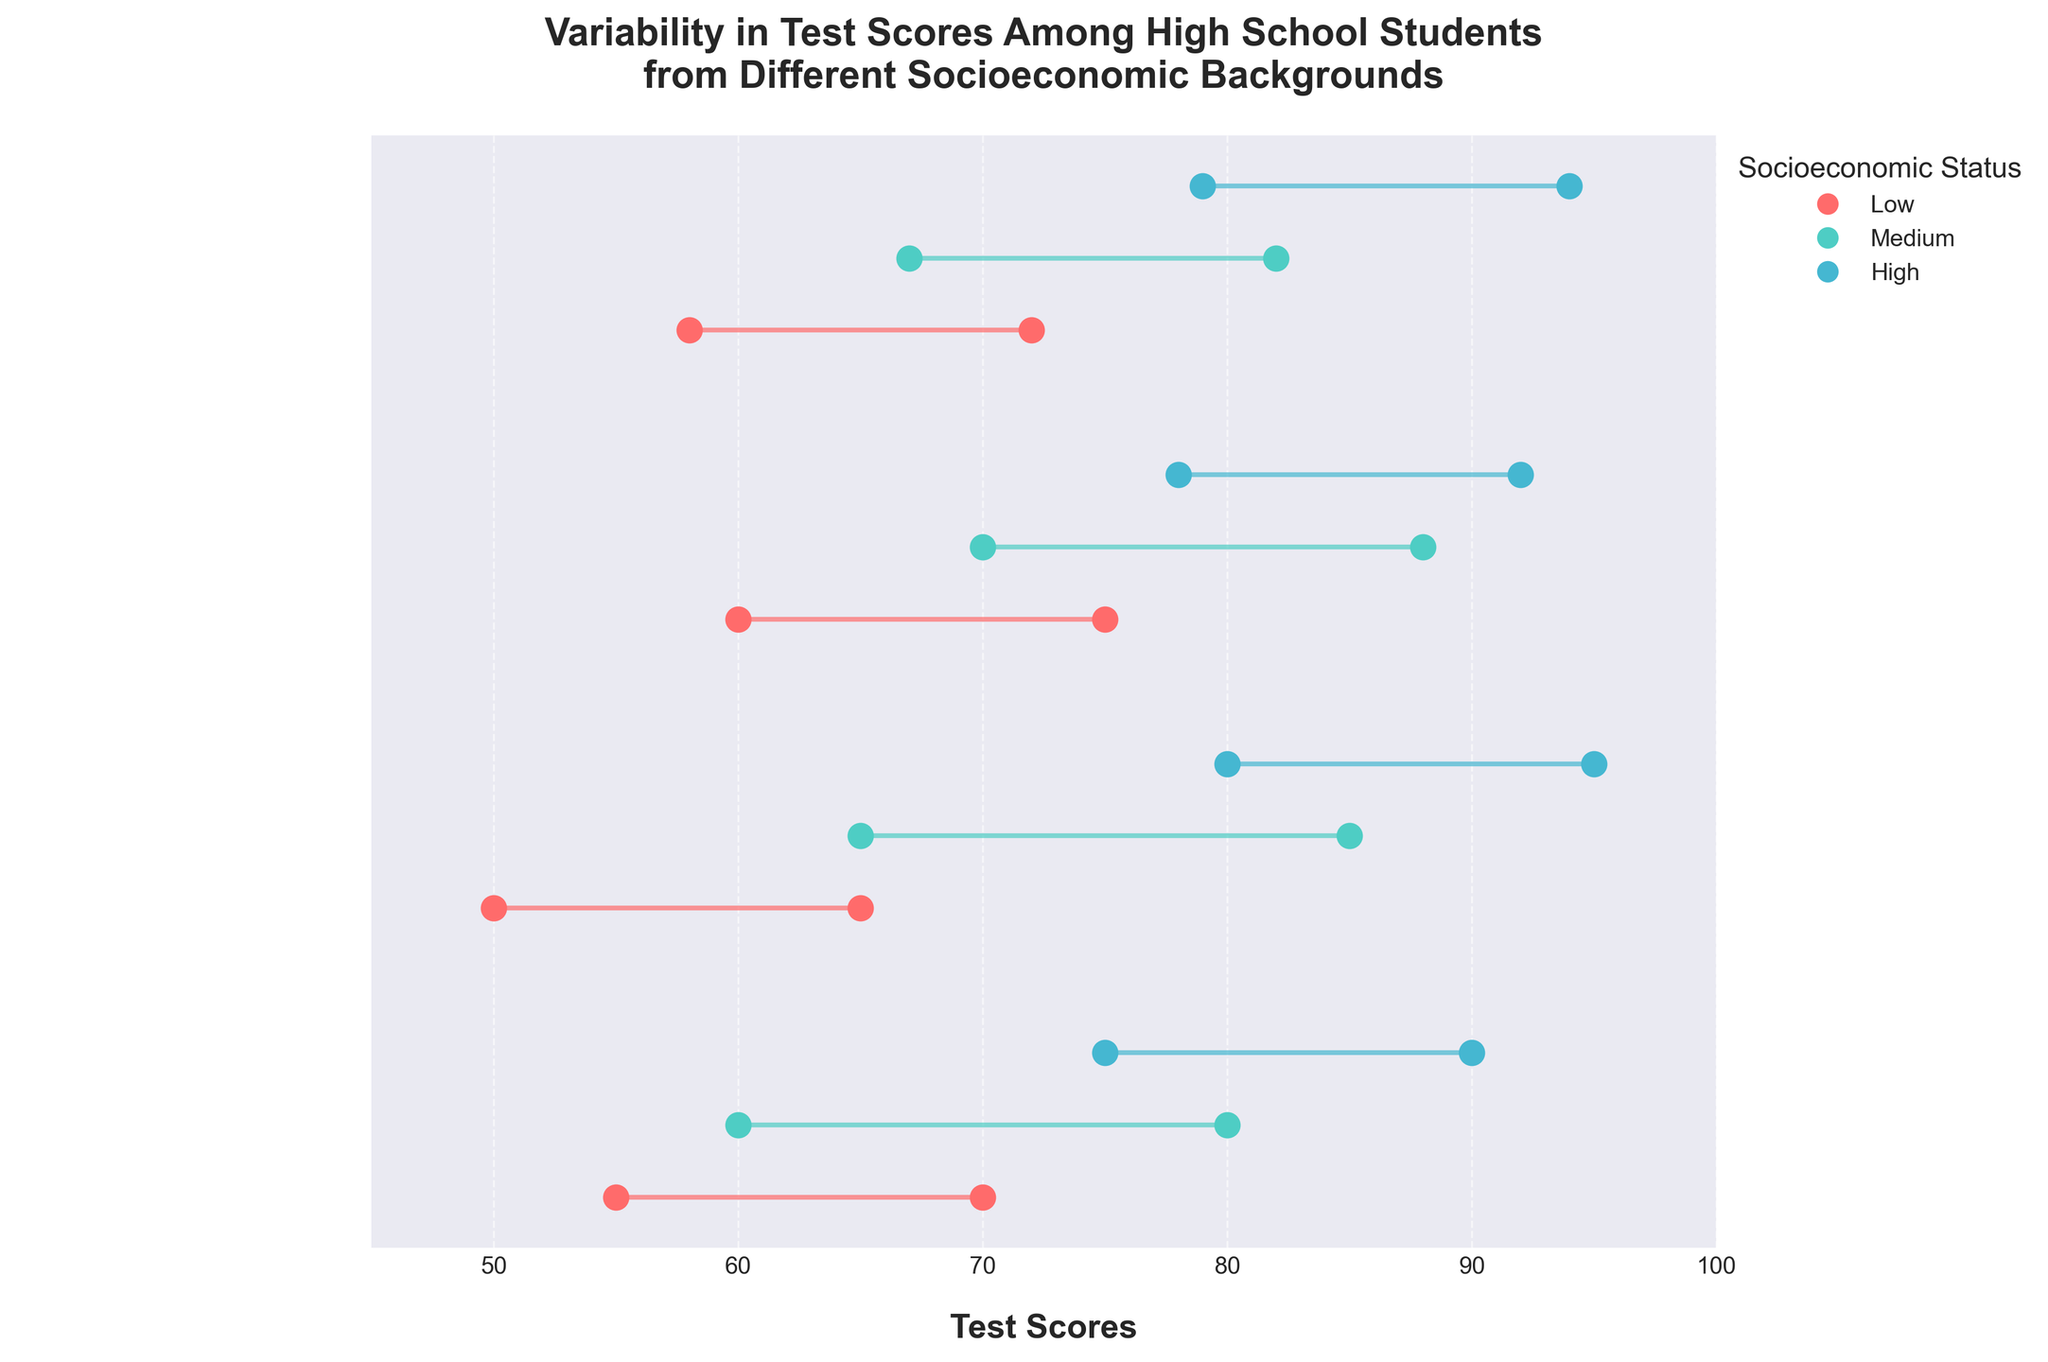what is the title of the plot? The title is usually placed at the top of the plot and it provides a concise description of what the figure represents. In this case, the title is "Variability in Test Scores Among High School Students from Different Socioeconomic Backgrounds."
Answer: Variability in Test Scores Among High School Students from Different Socioeconomic Backgrounds what colors represent the different socioeconomic status levels? The colors for each SES level are shown in the legend on the right side of the plot. Low is represented by red, Medium by teal, and High by blue.
Answer: red, teal, blue which high school has the widest range of test scores for students from a low socioeconomic background? To determine this, compare the length of the ranges (horizontal lines) for the "Low" SES category across all schools. Riverside High School has the widest range (50 to 65, which is 15).
Answer: Riverside High School what is the range of test scores for Greenwood High School's medium socioeconomic students? Look at the horizontal line for Greenwood High School corresponding to the "Medium" SES level. The low end is 70 and the high end is 88, so the range is 88 - 70 = 18.
Answer: 18 how does the variability in test scores for high socioeconomic students at Hillcrest High School compare to those at Riverside High School? Compare the length of the lines for the "High" SES level for both schools. Hillcrest High School has a range from 75 to 90 (15), and Riverside has a range from 80 to 95 (15). The ranges are the same.
Answer: The same which school's high socioeconomic status students have the highest maximum test score? Look at the highest point of the "High" SES lines for all schools. Riverside and Willow Creek both have a maximum of 95, the highest among all.
Answer: Riverside and Willow Creek what's the difference between the high end of the test scores for low SES students at Hillcrest High School and the low SES students at Willow Creek High School? Find the high end of the "Low" SES line for Hillcrest (70) and for Willow Creek (72). The difference is 72 - 70 = 2.
Answer: 2 which school has the smallest range of test scores for medium socioeconomic status students? Compare the range (length of the horizontal line) of the "Medium" SES category for all schools. Hillcrest High School has the smallest range with scores from 60 to 80 (20).
Answer: Hillcrest High School what are the test score ranges for each socioeconomic status at Willow Creek High School? Look at the horizontal lines for each SES level at Willow Creek High School. Low: 58 to 72, Medium: 67 to 82, High: 79 to 94.
Answer: Low: 58-72, Medium: 67-82, High: 79-94 